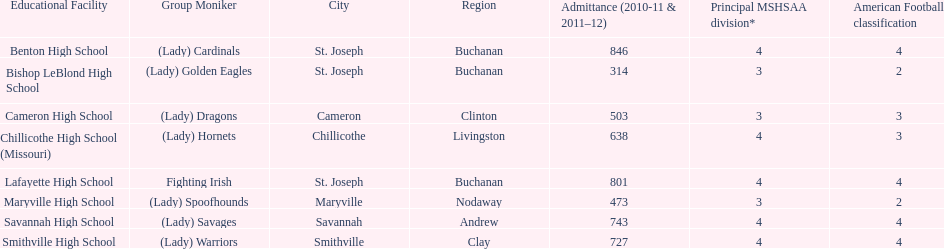What school has 3 football classes but only has 638 student enrollment? Chillicothe High School (Missouri). 